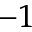<formula> <loc_0><loc_0><loc_500><loc_500>^ { - 1 }</formula> 